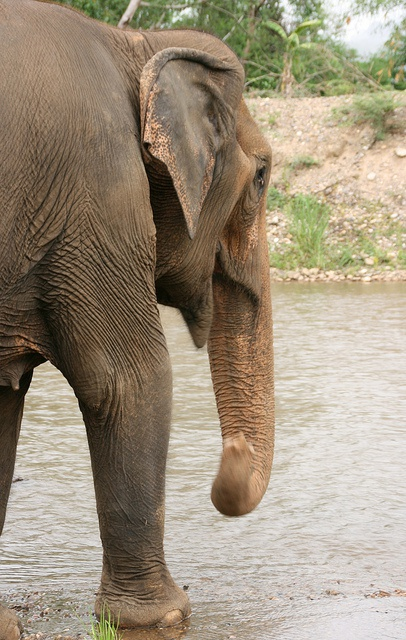Describe the objects in this image and their specific colors. I can see a elephant in gray, tan, and black tones in this image. 